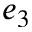<formula> <loc_0><loc_0><loc_500><loc_500>e _ { 3 }</formula> 